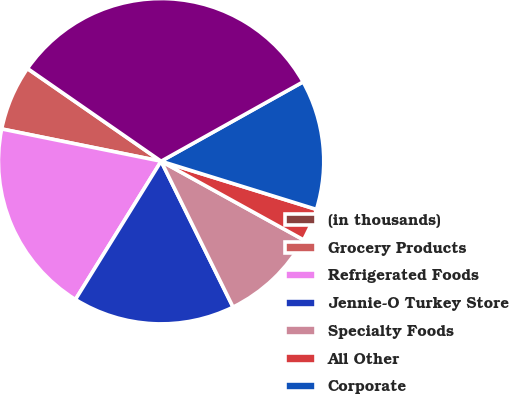<chart> <loc_0><loc_0><loc_500><loc_500><pie_chart><fcel>(in thousands)<fcel>Grocery Products<fcel>Refrigerated Foods<fcel>Jennie-O Turkey Store<fcel>Specialty Foods<fcel>All Other<fcel>Corporate<fcel>Total<nl><fcel>0.02%<fcel>6.46%<fcel>19.35%<fcel>16.12%<fcel>9.68%<fcel>3.24%<fcel>12.9%<fcel>32.23%<nl></chart> 